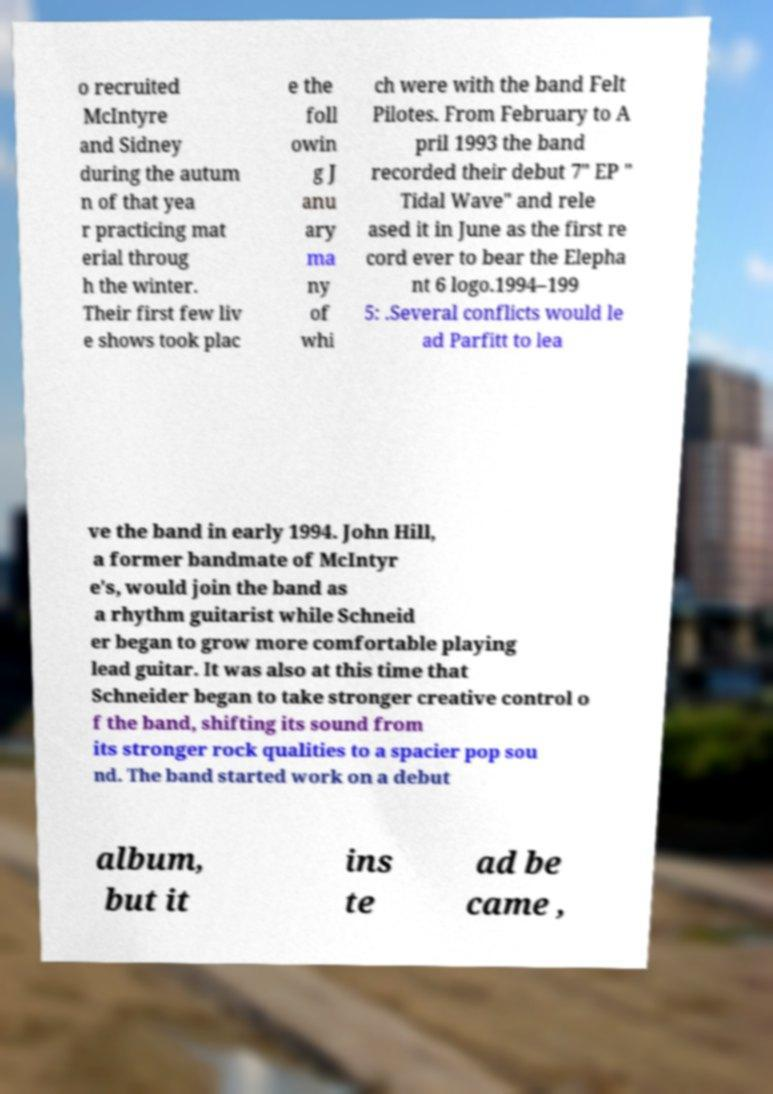I need the written content from this picture converted into text. Can you do that? o recruited McIntyre and Sidney during the autum n of that yea r practicing mat erial throug h the winter. Their first few liv e shows took plac e the foll owin g J anu ary ma ny of whi ch were with the band Felt Pilotes. From February to A pril 1993 the band recorded their debut 7" EP " Tidal Wave" and rele ased it in June as the first re cord ever to bear the Elepha nt 6 logo.1994–199 5: .Several conflicts would le ad Parfitt to lea ve the band in early 1994. John Hill, a former bandmate of McIntyr e's, would join the band as a rhythm guitarist while Schneid er began to grow more comfortable playing lead guitar. It was also at this time that Schneider began to take stronger creative control o f the band, shifting its sound from its stronger rock qualities to a spacier pop sou nd. The band started work on a debut album, but it ins te ad be came , 